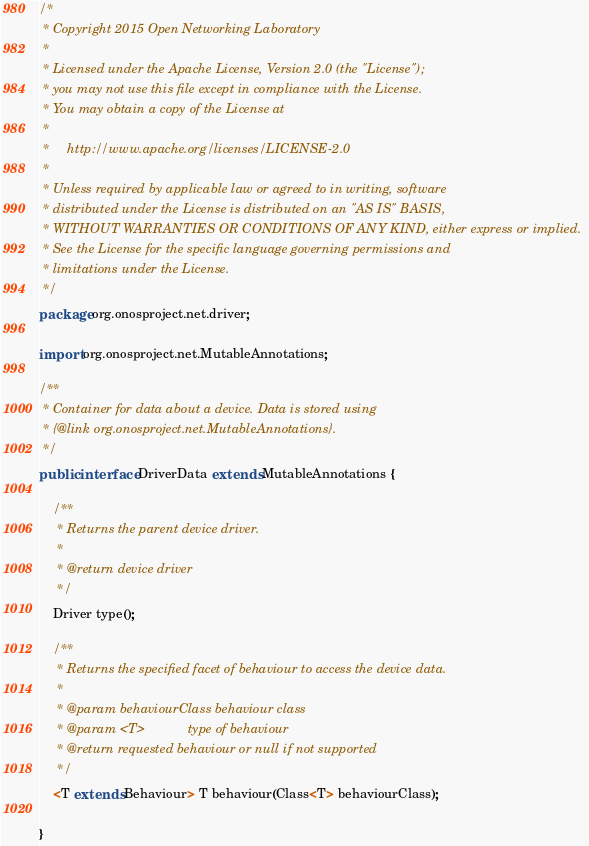Convert code to text. <code><loc_0><loc_0><loc_500><loc_500><_Java_>/*
 * Copyright 2015 Open Networking Laboratory
 *
 * Licensed under the Apache License, Version 2.0 (the "License");
 * you may not use this file except in compliance with the License.
 * You may obtain a copy of the License at
 *
 *     http://www.apache.org/licenses/LICENSE-2.0
 *
 * Unless required by applicable law or agreed to in writing, software
 * distributed under the License is distributed on an "AS IS" BASIS,
 * WITHOUT WARRANTIES OR CONDITIONS OF ANY KIND, either express or implied.
 * See the License for the specific language governing permissions and
 * limitations under the License.
 */
package org.onosproject.net.driver;

import org.onosproject.net.MutableAnnotations;

/**
 * Container for data about a device. Data is stored using
 * {@link org.onosproject.net.MutableAnnotations}.
 */
public interface DriverData extends MutableAnnotations {

    /**
     * Returns the parent device driver.
     *
     * @return device driver
     */
    Driver type();

    /**
     * Returns the specified facet of behaviour to access the device data.
     *
     * @param behaviourClass behaviour class
     * @param <T>            type of behaviour
     * @return requested behaviour or null if not supported
     */
    <T extends Behaviour> T behaviour(Class<T> behaviourClass);

}
</code> 